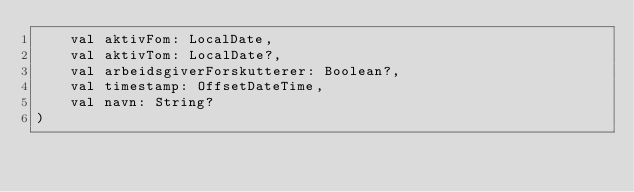Convert code to text. <code><loc_0><loc_0><loc_500><loc_500><_Kotlin_>    val aktivFom: LocalDate,
    val aktivTom: LocalDate?,
    val arbeidsgiverForskutterer: Boolean?,
    val timestamp: OffsetDateTime,
    val navn: String?
)
</code> 